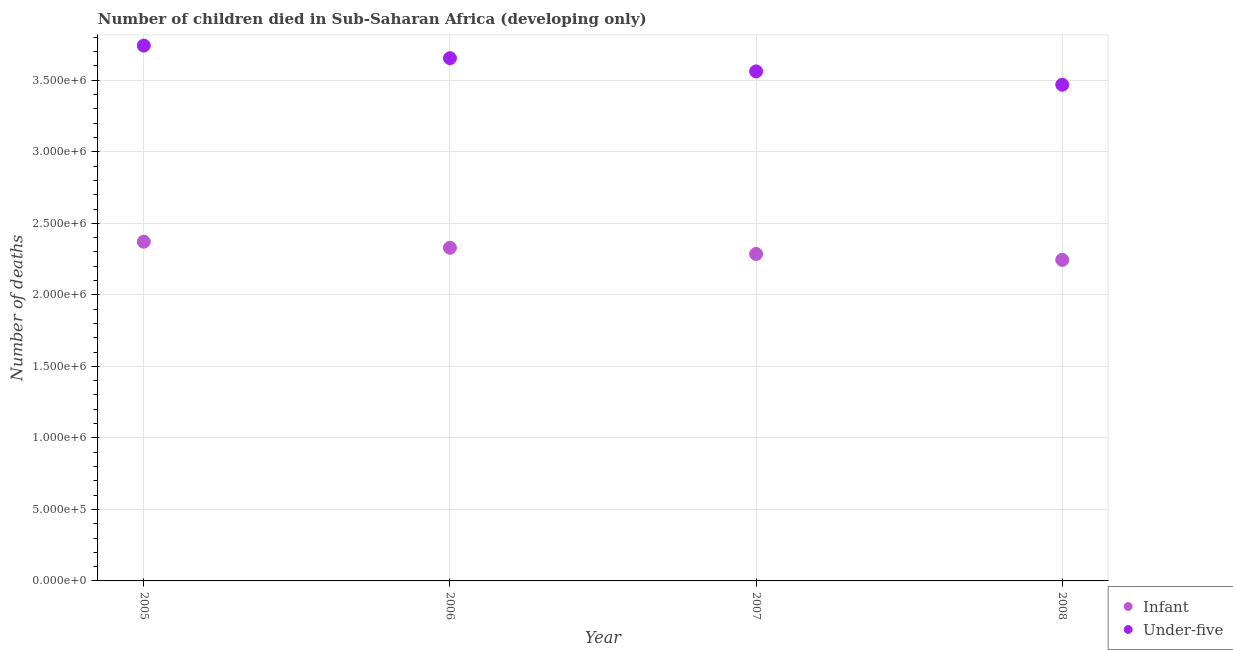How many different coloured dotlines are there?
Make the answer very short. 2. What is the number of under-five deaths in 2005?
Your response must be concise. 3.74e+06. Across all years, what is the maximum number of infant deaths?
Provide a succinct answer. 2.37e+06. Across all years, what is the minimum number of under-five deaths?
Give a very brief answer. 3.47e+06. In which year was the number of infant deaths minimum?
Make the answer very short. 2008. What is the total number of under-five deaths in the graph?
Give a very brief answer. 1.44e+07. What is the difference between the number of infant deaths in 2005 and that in 2007?
Give a very brief answer. 8.59e+04. What is the difference between the number of under-five deaths in 2008 and the number of infant deaths in 2005?
Your answer should be compact. 1.10e+06. What is the average number of under-five deaths per year?
Your answer should be compact. 3.61e+06. In the year 2007, what is the difference between the number of under-five deaths and number of infant deaths?
Offer a terse response. 1.28e+06. In how many years, is the number of under-five deaths greater than 3000000?
Ensure brevity in your answer.  4. What is the ratio of the number of under-five deaths in 2006 to that in 2007?
Keep it short and to the point. 1.03. Is the difference between the number of infant deaths in 2005 and 2006 greater than the difference between the number of under-five deaths in 2005 and 2006?
Offer a very short reply. No. What is the difference between the highest and the second highest number of under-five deaths?
Your response must be concise. 8.80e+04. What is the difference between the highest and the lowest number of under-five deaths?
Provide a short and direct response. 2.74e+05. Is the sum of the number of under-five deaths in 2005 and 2008 greater than the maximum number of infant deaths across all years?
Ensure brevity in your answer.  Yes. Does the number of infant deaths monotonically increase over the years?
Keep it short and to the point. No. Is the number of under-five deaths strictly greater than the number of infant deaths over the years?
Make the answer very short. Yes. Is the number of under-five deaths strictly less than the number of infant deaths over the years?
Your answer should be very brief. No. What is the difference between two consecutive major ticks on the Y-axis?
Make the answer very short. 5.00e+05. Are the values on the major ticks of Y-axis written in scientific E-notation?
Give a very brief answer. Yes. Does the graph contain grids?
Offer a terse response. Yes. Where does the legend appear in the graph?
Ensure brevity in your answer.  Bottom right. How many legend labels are there?
Provide a succinct answer. 2. How are the legend labels stacked?
Your response must be concise. Vertical. What is the title of the graph?
Keep it short and to the point. Number of children died in Sub-Saharan Africa (developing only). Does "International Tourists" appear as one of the legend labels in the graph?
Your answer should be very brief. No. What is the label or title of the X-axis?
Keep it short and to the point. Year. What is the label or title of the Y-axis?
Provide a short and direct response. Number of deaths. What is the Number of deaths of Infant in 2005?
Provide a short and direct response. 2.37e+06. What is the Number of deaths of Under-five in 2005?
Offer a terse response. 3.74e+06. What is the Number of deaths in Infant in 2006?
Ensure brevity in your answer.  2.33e+06. What is the Number of deaths of Under-five in 2006?
Your response must be concise. 3.65e+06. What is the Number of deaths of Infant in 2007?
Provide a short and direct response. 2.29e+06. What is the Number of deaths in Under-five in 2007?
Provide a short and direct response. 3.56e+06. What is the Number of deaths in Infant in 2008?
Provide a short and direct response. 2.24e+06. What is the Number of deaths of Under-five in 2008?
Your response must be concise. 3.47e+06. Across all years, what is the maximum Number of deaths of Infant?
Keep it short and to the point. 2.37e+06. Across all years, what is the maximum Number of deaths of Under-five?
Your answer should be very brief. 3.74e+06. Across all years, what is the minimum Number of deaths in Infant?
Ensure brevity in your answer.  2.24e+06. Across all years, what is the minimum Number of deaths of Under-five?
Make the answer very short. 3.47e+06. What is the total Number of deaths of Infant in the graph?
Your response must be concise. 9.23e+06. What is the total Number of deaths in Under-five in the graph?
Give a very brief answer. 1.44e+07. What is the difference between the Number of deaths in Infant in 2005 and that in 2006?
Your response must be concise. 4.25e+04. What is the difference between the Number of deaths in Under-five in 2005 and that in 2006?
Make the answer very short. 8.80e+04. What is the difference between the Number of deaths in Infant in 2005 and that in 2007?
Your response must be concise. 8.59e+04. What is the difference between the Number of deaths of Under-five in 2005 and that in 2007?
Your answer should be very brief. 1.80e+05. What is the difference between the Number of deaths of Infant in 2005 and that in 2008?
Offer a very short reply. 1.27e+05. What is the difference between the Number of deaths in Under-five in 2005 and that in 2008?
Keep it short and to the point. 2.74e+05. What is the difference between the Number of deaths in Infant in 2006 and that in 2007?
Make the answer very short. 4.33e+04. What is the difference between the Number of deaths in Under-five in 2006 and that in 2007?
Provide a succinct answer. 9.24e+04. What is the difference between the Number of deaths of Infant in 2006 and that in 2008?
Offer a very short reply. 8.45e+04. What is the difference between the Number of deaths of Under-five in 2006 and that in 2008?
Provide a short and direct response. 1.86e+05. What is the difference between the Number of deaths of Infant in 2007 and that in 2008?
Give a very brief answer. 4.12e+04. What is the difference between the Number of deaths of Under-five in 2007 and that in 2008?
Provide a short and direct response. 9.33e+04. What is the difference between the Number of deaths of Infant in 2005 and the Number of deaths of Under-five in 2006?
Offer a terse response. -1.28e+06. What is the difference between the Number of deaths of Infant in 2005 and the Number of deaths of Under-five in 2007?
Provide a succinct answer. -1.19e+06. What is the difference between the Number of deaths in Infant in 2005 and the Number of deaths in Under-five in 2008?
Offer a very short reply. -1.10e+06. What is the difference between the Number of deaths in Infant in 2006 and the Number of deaths in Under-five in 2007?
Your answer should be very brief. -1.23e+06. What is the difference between the Number of deaths of Infant in 2006 and the Number of deaths of Under-five in 2008?
Your answer should be very brief. -1.14e+06. What is the difference between the Number of deaths in Infant in 2007 and the Number of deaths in Under-five in 2008?
Your answer should be compact. -1.18e+06. What is the average Number of deaths of Infant per year?
Offer a terse response. 2.31e+06. What is the average Number of deaths in Under-five per year?
Give a very brief answer. 3.61e+06. In the year 2005, what is the difference between the Number of deaths of Infant and Number of deaths of Under-five?
Ensure brevity in your answer.  -1.37e+06. In the year 2006, what is the difference between the Number of deaths in Infant and Number of deaths in Under-five?
Provide a short and direct response. -1.33e+06. In the year 2007, what is the difference between the Number of deaths of Infant and Number of deaths of Under-five?
Your answer should be compact. -1.28e+06. In the year 2008, what is the difference between the Number of deaths in Infant and Number of deaths in Under-five?
Your response must be concise. -1.22e+06. What is the ratio of the Number of deaths of Infant in 2005 to that in 2006?
Your answer should be very brief. 1.02. What is the ratio of the Number of deaths of Under-five in 2005 to that in 2006?
Provide a succinct answer. 1.02. What is the ratio of the Number of deaths of Infant in 2005 to that in 2007?
Give a very brief answer. 1.04. What is the ratio of the Number of deaths of Under-five in 2005 to that in 2007?
Offer a very short reply. 1.05. What is the ratio of the Number of deaths in Infant in 2005 to that in 2008?
Provide a succinct answer. 1.06. What is the ratio of the Number of deaths in Under-five in 2005 to that in 2008?
Offer a very short reply. 1.08. What is the ratio of the Number of deaths in Under-five in 2006 to that in 2007?
Provide a short and direct response. 1.03. What is the ratio of the Number of deaths in Infant in 2006 to that in 2008?
Offer a very short reply. 1.04. What is the ratio of the Number of deaths of Under-five in 2006 to that in 2008?
Keep it short and to the point. 1.05. What is the ratio of the Number of deaths of Infant in 2007 to that in 2008?
Make the answer very short. 1.02. What is the ratio of the Number of deaths in Under-five in 2007 to that in 2008?
Provide a succinct answer. 1.03. What is the difference between the highest and the second highest Number of deaths of Infant?
Make the answer very short. 4.25e+04. What is the difference between the highest and the second highest Number of deaths of Under-five?
Give a very brief answer. 8.80e+04. What is the difference between the highest and the lowest Number of deaths of Infant?
Provide a succinct answer. 1.27e+05. What is the difference between the highest and the lowest Number of deaths in Under-five?
Provide a short and direct response. 2.74e+05. 